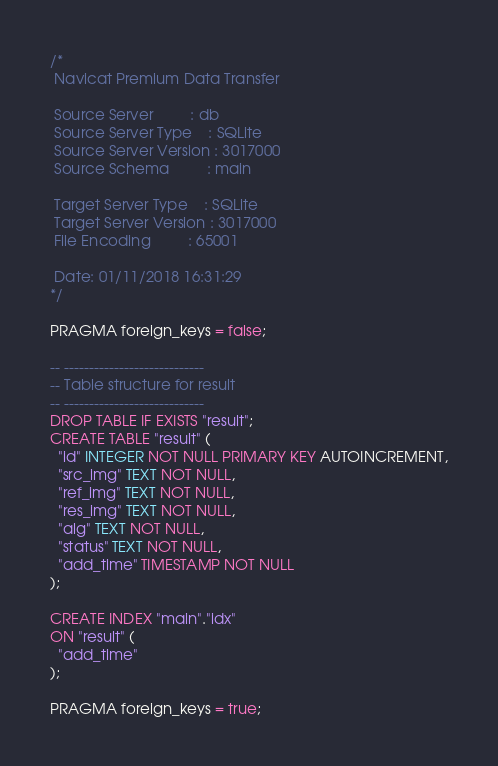Convert code to text. <code><loc_0><loc_0><loc_500><loc_500><_SQL_>/*
 Navicat Premium Data Transfer

 Source Server         : db
 Source Server Type    : SQLite
 Source Server Version : 3017000
 Source Schema         : main

 Target Server Type    : SQLite
 Target Server Version : 3017000
 File Encoding         : 65001

 Date: 01/11/2018 16:31:29
*/

PRAGMA foreign_keys = false;

-- ----------------------------
-- Table structure for result
-- ----------------------------
DROP TABLE IF EXISTS "result";
CREATE TABLE "result" (
  "id" INTEGER NOT NULL PRIMARY KEY AUTOINCREMENT,
  "src_img" TEXT NOT NULL,
  "ref_img" TEXT NOT NULL,
  "res_img" TEXT NOT NULL,
  "alg" TEXT NOT NULL,
  "status" TEXT NOT NULL,
  "add_time" TIMESTAMP NOT NULL
);

CREATE INDEX "main"."idx"
ON "result" (
  "add_time"
);

PRAGMA foreign_keys = true;
</code> 